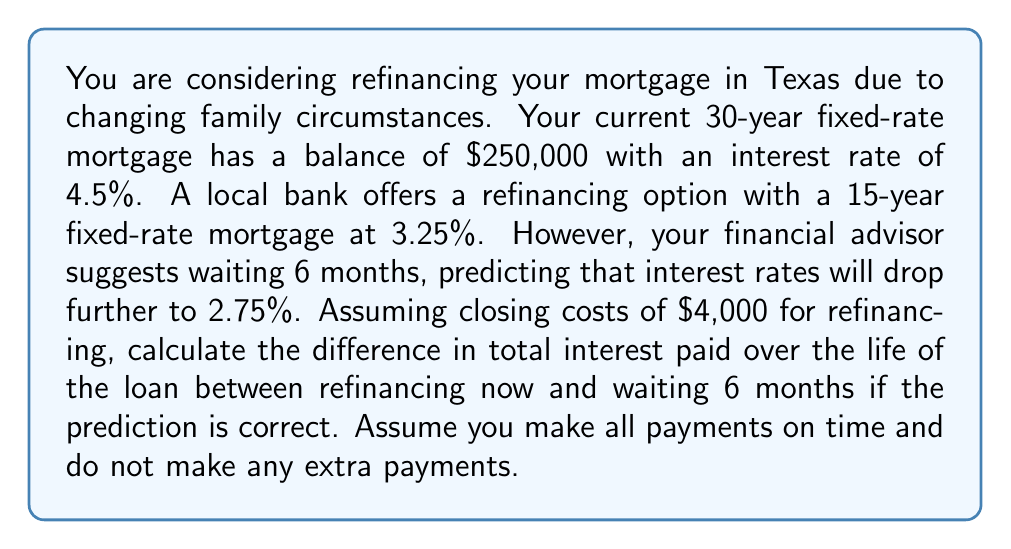What is the answer to this math problem? Let's approach this problem step-by-step:

1. Calculate the monthly payment for the current mortgage:
   Using the formula: $P = L\frac{r(1+r)^n}{(1+r)^n-1}$
   Where $P$ is the monthly payment, $L$ is the loan amount, $r$ is the monthly interest rate, and $n$ is the number of months.

   $r = \frac{4.5\%}{12} = 0.00375$
   $n = 30 \times 12 = 360$

   $$P = 250000\frac{0.00375(1+0.00375)^{360}}{(1+0.00375)^{360}-1} = 1266.71$$

2. Calculate the total interest for the current mortgage:
   Total interest = (Monthly payment × Number of months) - Original loan amount
   $$ 1266.71 \times 360 - 250000 = 206015.60 $$

3. Calculate the monthly payment for refinancing now (3.25%, 15 years):
   $r = \frac{3.25\%}{12} = 0.002708333$
   $n = 15 \times 12 = 180$

   $$P = 250000\frac{0.002708333(1+0.002708333)^{180}}{(1+0.002708333)^{180}-1} = 1756.14$$

4. Calculate the total interest for refinancing now:
   $$ 1756.14 \times 180 - 250000 = 66105.20 $$

5. Calculate the monthly payment for refinancing in 6 months (2.75%, 15 years):
   $r = \frac{2.75\%}{12} = 0.002291667$
   $n = 15 \times 12 = 180$

   $$P = 250000\frac{0.002291667(1+0.002291667)^{180}}{(1+0.002291667)^{180}-1} = 1696.49$$

6. Calculate the total interest for refinancing in 6 months:
   $$ 1696.49 \times 180 - 250000 = 55368.20 $$

7. Calculate the difference in total interest paid:
   Difference = (Interest paid refinancing now + Closing costs) - (Interest paid refinancing in 6 months + Closing costs)
   $$ (66105.20 + 4000) - (55368.20 + 4000) = 10737.00 $$
Answer: $10,737.00 